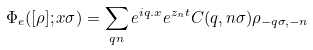<formula> <loc_0><loc_0><loc_500><loc_500>\Phi _ { e } ( [ \rho ] ; { x } \sigma ) = \sum _ { { q } n } e ^ { i { q . x } } e ^ { z _ { n } t } C ( { q } , n \sigma ) \rho _ { - { q } \sigma , - n }</formula> 